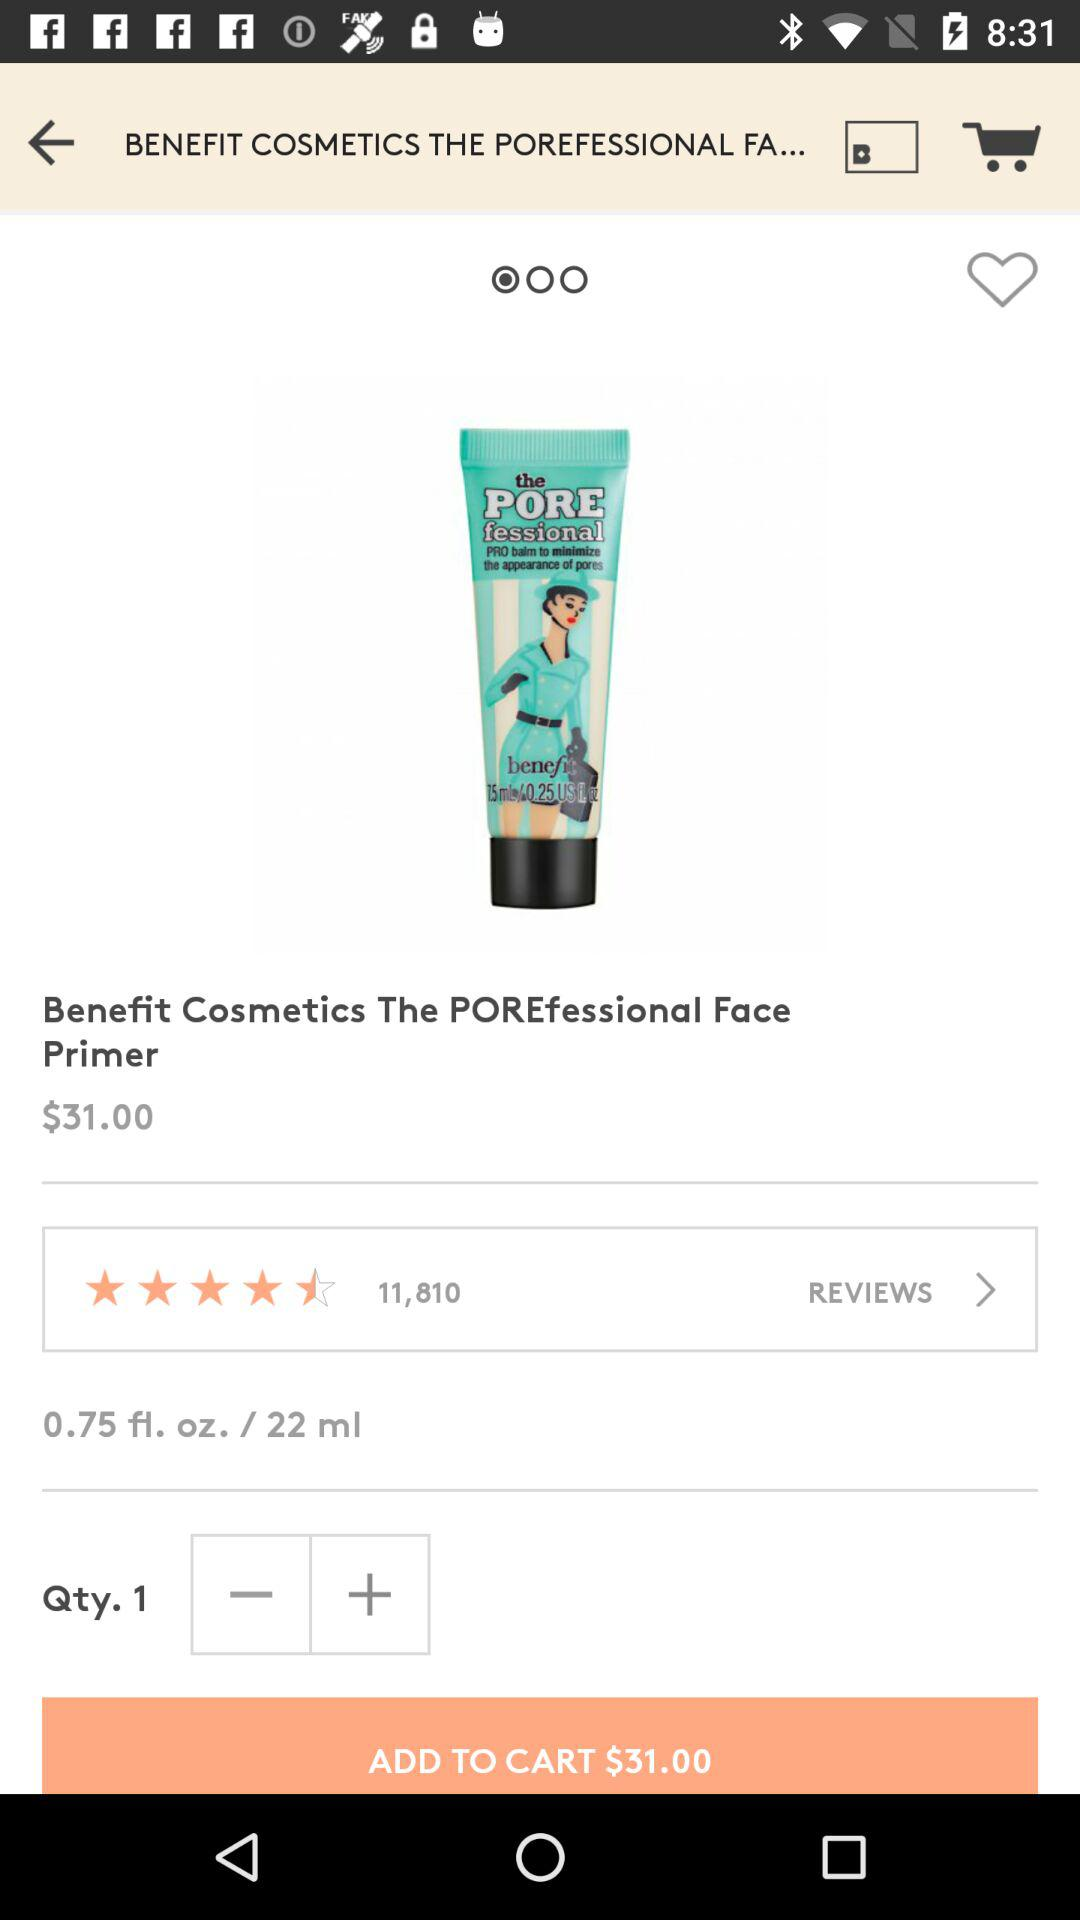How many reviews are there for the product? There are 11,810 reviews. 